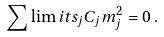Convert formula to latex. <formula><loc_0><loc_0><loc_500><loc_500>\sum \lim i t s _ { j } { C _ { j } } { m _ { j } ^ { 2 } } = 0 \, .</formula> 